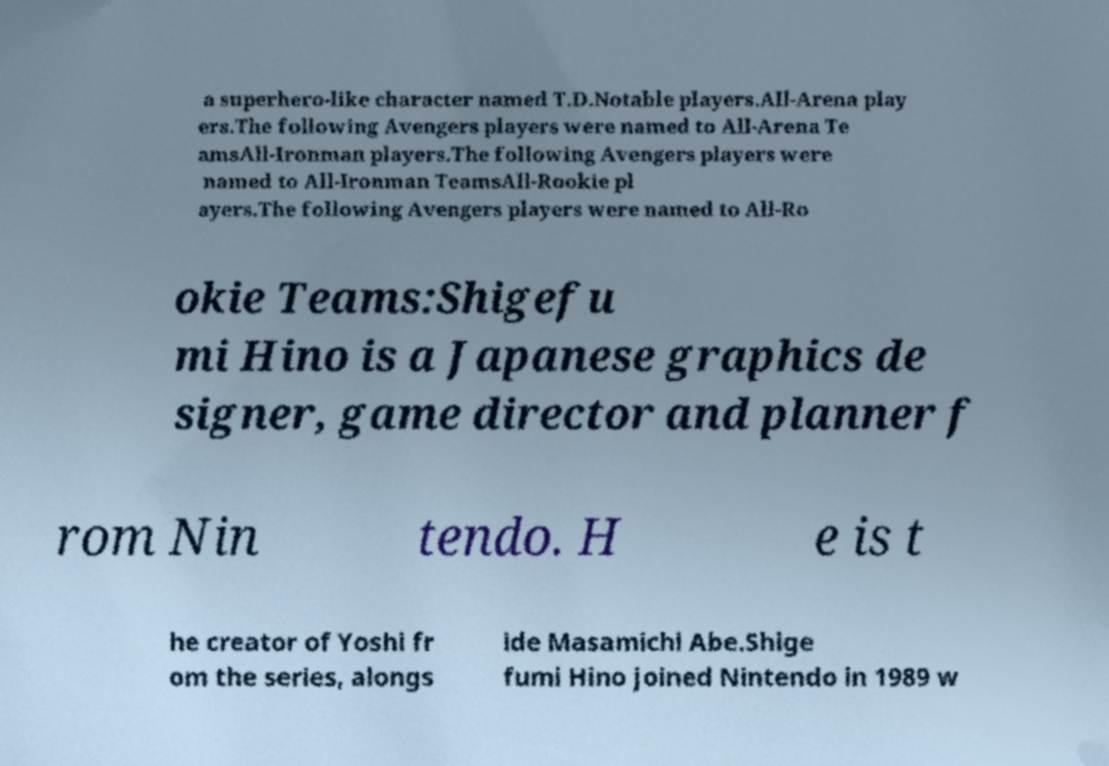Please identify and transcribe the text found in this image. a superhero-like character named T.D.Notable players.All-Arena play ers.The following Avengers players were named to All-Arena Te amsAll-Ironman players.The following Avengers players were named to All-Ironman TeamsAll-Rookie pl ayers.The following Avengers players were named to All-Ro okie Teams:Shigefu mi Hino is a Japanese graphics de signer, game director and planner f rom Nin tendo. H e is t he creator of Yoshi fr om the series, alongs ide Masamichi Abe.Shige fumi Hino joined Nintendo in 1989 w 